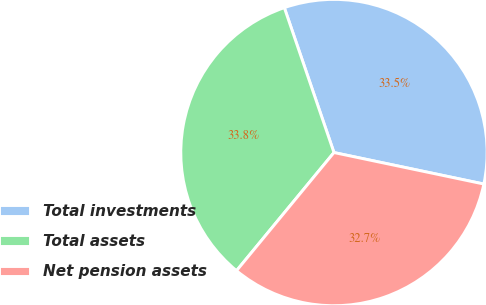Convert chart. <chart><loc_0><loc_0><loc_500><loc_500><pie_chart><fcel>Total investments<fcel>Total assets<fcel>Net pension assets<nl><fcel>33.55%<fcel>33.77%<fcel>32.68%<nl></chart> 